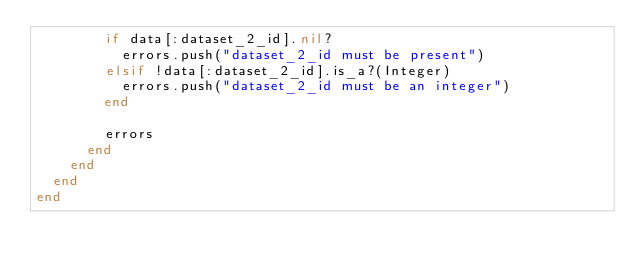Convert code to text. <code><loc_0><loc_0><loc_500><loc_500><_Ruby_>        if data[:dataset_2_id].nil?
          errors.push("dataset_2_id must be present")
        elsif !data[:dataset_2_id].is_a?(Integer)
          errors.push("dataset_2_id must be an integer")
        end

        errors
      end
    end
  end
end
</code> 